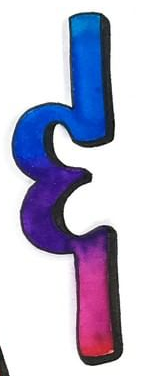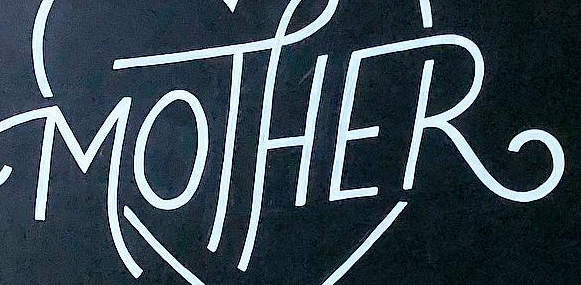Identify the words shown in these images in order, separated by a semicolon. &; MOTHER 